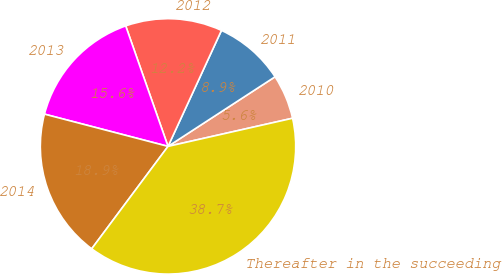<chart> <loc_0><loc_0><loc_500><loc_500><pie_chart><fcel>2010<fcel>2011<fcel>2012<fcel>2013<fcel>2014<fcel>Thereafter in the succeeding<nl><fcel>5.64%<fcel>8.95%<fcel>12.25%<fcel>15.56%<fcel>18.87%<fcel>38.73%<nl></chart> 